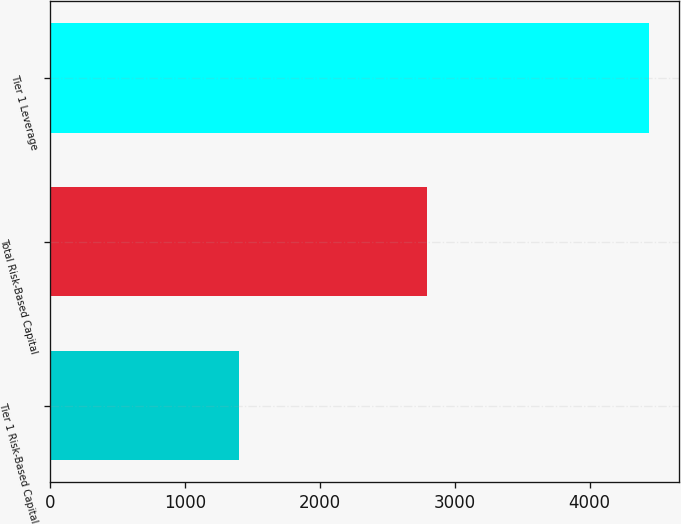Convert chart to OTSL. <chart><loc_0><loc_0><loc_500><loc_500><bar_chart><fcel>Tier 1 Risk-Based Capital<fcel>Total Risk-Based Capital<fcel>Tier 1 Leverage<nl><fcel>1397<fcel>2793<fcel>4438<nl></chart> 